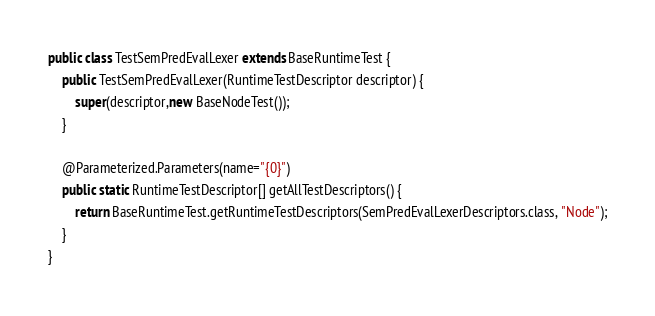Convert code to text. <code><loc_0><loc_0><loc_500><loc_500><_Java_>public class TestSemPredEvalLexer extends BaseRuntimeTest {
	public TestSemPredEvalLexer(RuntimeTestDescriptor descriptor) {
		super(descriptor,new BaseNodeTest());
	}

	@Parameterized.Parameters(name="{0}")
	public static RuntimeTestDescriptor[] getAllTestDescriptors() {
		return BaseRuntimeTest.getRuntimeTestDescriptors(SemPredEvalLexerDescriptors.class, "Node");
	}
}
</code> 